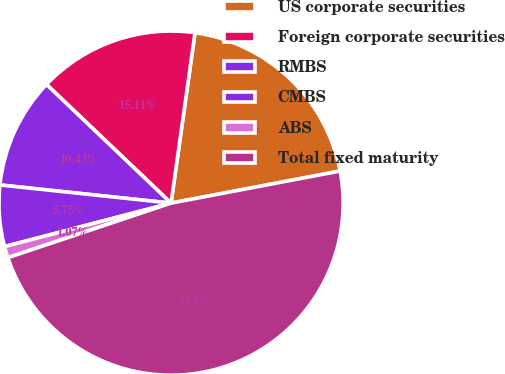Convert chart. <chart><loc_0><loc_0><loc_500><loc_500><pie_chart><fcel>US corporate securities<fcel>Foreign corporate securities<fcel>RMBS<fcel>CMBS<fcel>ABS<fcel>Total fixed maturity<nl><fcel>19.79%<fcel>15.11%<fcel>10.43%<fcel>5.75%<fcel>1.07%<fcel>47.85%<nl></chart> 